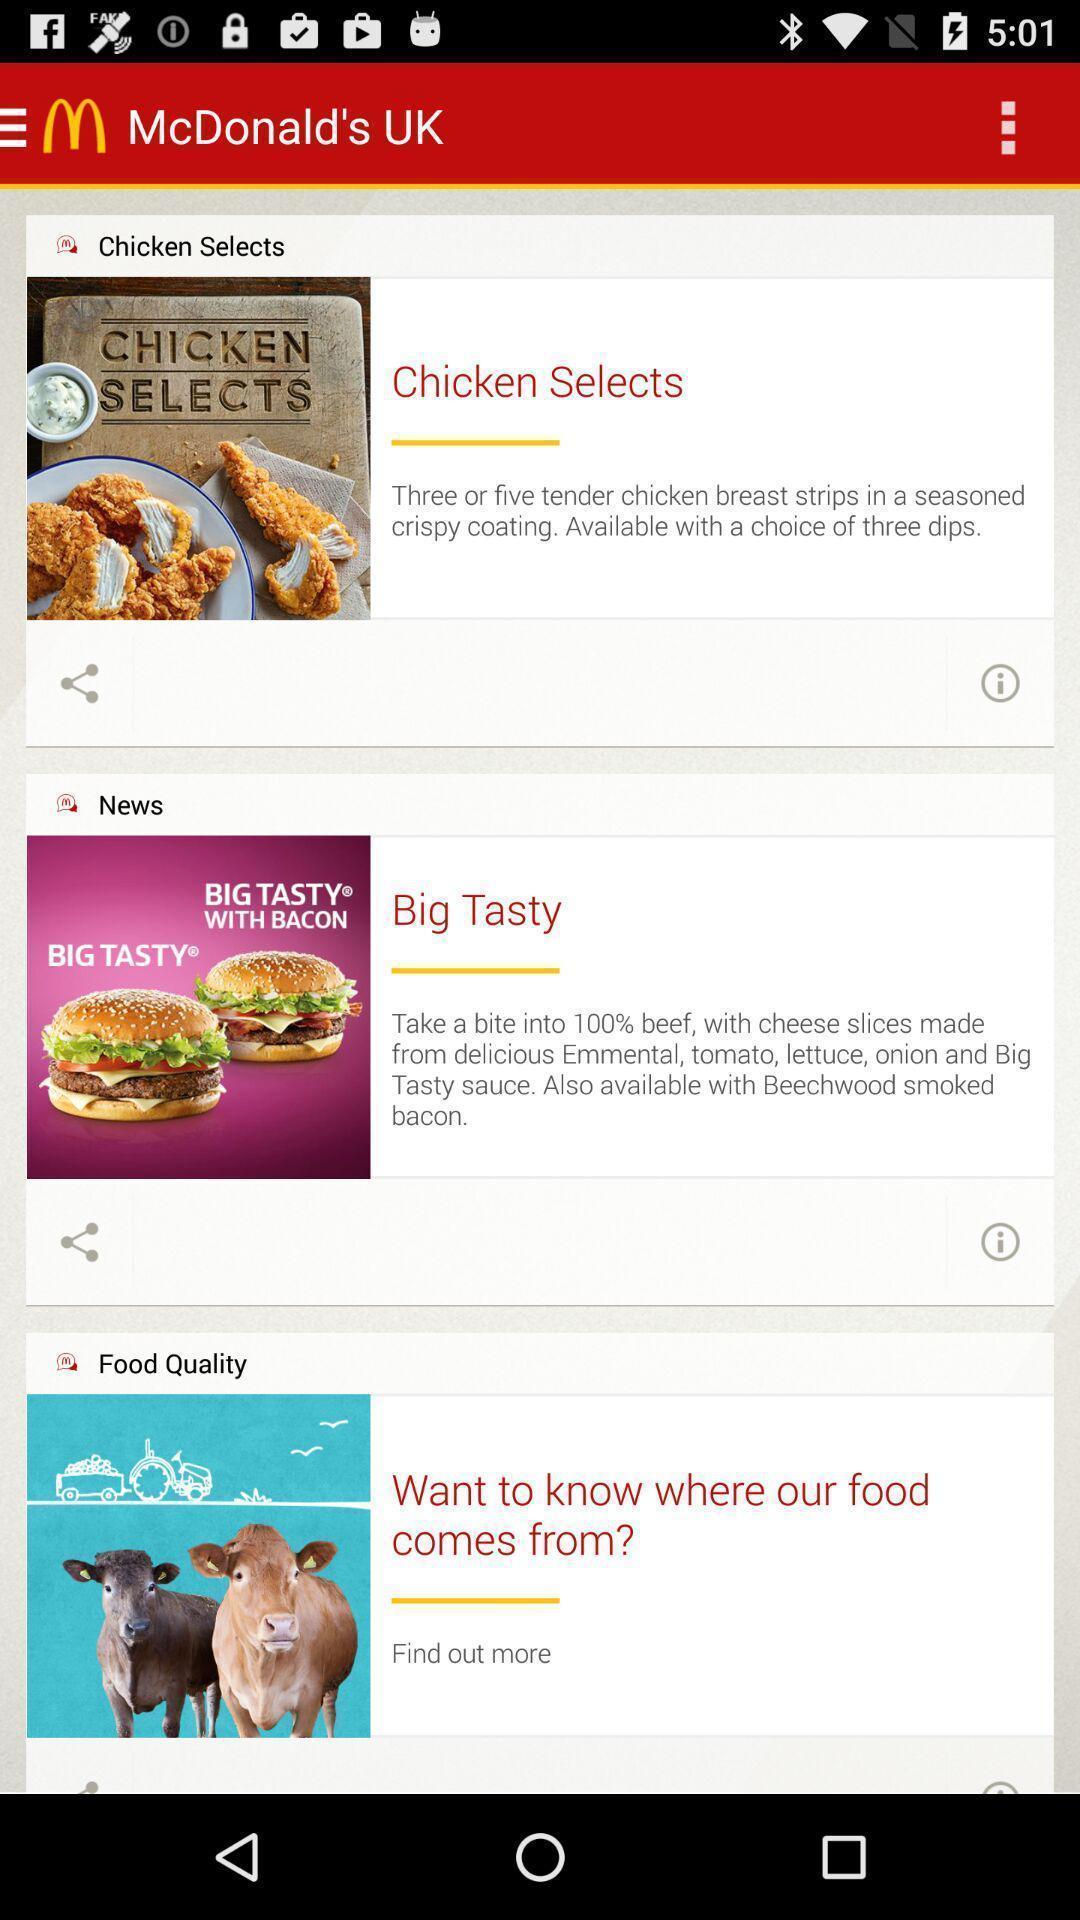Explain the elements present in this screenshot. Screen showing page of an food application. 